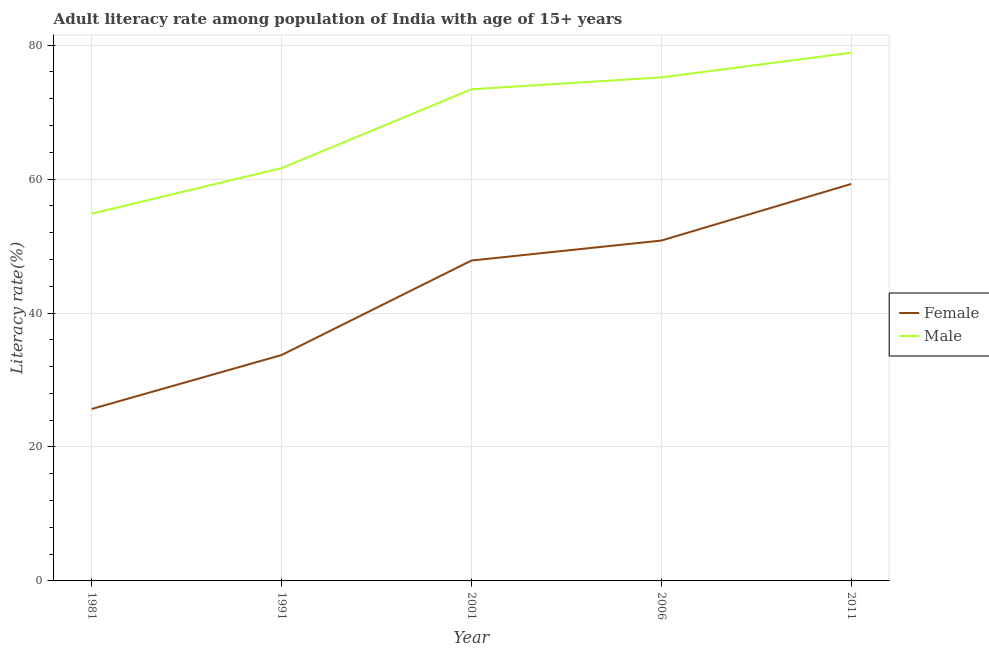How many different coloured lines are there?
Provide a short and direct response. 2. Does the line corresponding to female adult literacy rate intersect with the line corresponding to male adult literacy rate?
Your answer should be compact. No. What is the male adult literacy rate in 2001?
Keep it short and to the point. 73.41. Across all years, what is the maximum female adult literacy rate?
Your answer should be compact. 59.28. Across all years, what is the minimum male adult literacy rate?
Offer a very short reply. 54.84. What is the total male adult literacy rate in the graph?
Your answer should be very brief. 343.96. What is the difference between the female adult literacy rate in 1981 and that in 1991?
Make the answer very short. -8.05. What is the difference between the male adult literacy rate in 1991 and the female adult literacy rate in 2001?
Give a very brief answer. 13.8. What is the average male adult literacy rate per year?
Make the answer very short. 68.79. In the year 1981, what is the difference between the male adult literacy rate and female adult literacy rate?
Give a very brief answer. 29.16. In how many years, is the female adult literacy rate greater than 8 %?
Make the answer very short. 5. What is the ratio of the female adult literacy rate in 2001 to that in 2011?
Provide a short and direct response. 0.81. Is the difference between the female adult literacy rate in 2001 and 2011 greater than the difference between the male adult literacy rate in 2001 and 2011?
Give a very brief answer. No. What is the difference between the highest and the second highest male adult literacy rate?
Offer a terse response. 3.69. What is the difference between the highest and the lowest female adult literacy rate?
Provide a succinct answer. 33.6. Is the sum of the female adult literacy rate in 1991 and 2011 greater than the maximum male adult literacy rate across all years?
Make the answer very short. Yes. Is the female adult literacy rate strictly greater than the male adult literacy rate over the years?
Provide a succinct answer. No. Is the female adult literacy rate strictly less than the male adult literacy rate over the years?
Offer a very short reply. Yes. How many lines are there?
Offer a very short reply. 2. How many years are there in the graph?
Your answer should be compact. 5. What is the difference between two consecutive major ticks on the Y-axis?
Make the answer very short. 20. Are the values on the major ticks of Y-axis written in scientific E-notation?
Keep it short and to the point. No. Does the graph contain any zero values?
Offer a terse response. No. Does the graph contain grids?
Ensure brevity in your answer.  Yes. How are the legend labels stacked?
Your answer should be very brief. Vertical. What is the title of the graph?
Provide a short and direct response. Adult literacy rate among population of India with age of 15+ years. Does "Drinking water services" appear as one of the legend labels in the graph?
Your answer should be compact. No. What is the label or title of the X-axis?
Your response must be concise. Year. What is the label or title of the Y-axis?
Offer a terse response. Literacy rate(%). What is the Literacy rate(%) in Female in 1981?
Your answer should be compact. 25.68. What is the Literacy rate(%) of Male in 1981?
Keep it short and to the point. 54.84. What is the Literacy rate(%) in Female in 1991?
Your answer should be compact. 33.73. What is the Literacy rate(%) in Male in 1991?
Your answer should be very brief. 61.64. What is the Literacy rate(%) of Female in 2001?
Keep it short and to the point. 47.84. What is the Literacy rate(%) of Male in 2001?
Offer a very short reply. 73.41. What is the Literacy rate(%) of Female in 2006?
Give a very brief answer. 50.82. What is the Literacy rate(%) of Male in 2006?
Make the answer very short. 75.19. What is the Literacy rate(%) in Female in 2011?
Give a very brief answer. 59.28. What is the Literacy rate(%) of Male in 2011?
Offer a terse response. 78.88. Across all years, what is the maximum Literacy rate(%) of Female?
Your answer should be very brief. 59.28. Across all years, what is the maximum Literacy rate(%) of Male?
Your answer should be compact. 78.88. Across all years, what is the minimum Literacy rate(%) in Female?
Keep it short and to the point. 25.68. Across all years, what is the minimum Literacy rate(%) of Male?
Give a very brief answer. 54.84. What is the total Literacy rate(%) of Female in the graph?
Make the answer very short. 217.35. What is the total Literacy rate(%) of Male in the graph?
Make the answer very short. 343.96. What is the difference between the Literacy rate(%) in Female in 1981 and that in 1991?
Offer a very short reply. -8.05. What is the difference between the Literacy rate(%) of Male in 1981 and that in 1991?
Offer a terse response. -6.8. What is the difference between the Literacy rate(%) of Female in 1981 and that in 2001?
Provide a short and direct response. -22.17. What is the difference between the Literacy rate(%) of Male in 1981 and that in 2001?
Your answer should be very brief. -18.57. What is the difference between the Literacy rate(%) of Female in 1981 and that in 2006?
Your answer should be compact. -25.15. What is the difference between the Literacy rate(%) of Male in 1981 and that in 2006?
Your answer should be very brief. -20.35. What is the difference between the Literacy rate(%) in Female in 1981 and that in 2011?
Make the answer very short. -33.6. What is the difference between the Literacy rate(%) of Male in 1981 and that in 2011?
Keep it short and to the point. -24.04. What is the difference between the Literacy rate(%) of Female in 1991 and that in 2001?
Give a very brief answer. -14.11. What is the difference between the Literacy rate(%) of Male in 1991 and that in 2001?
Keep it short and to the point. -11.77. What is the difference between the Literacy rate(%) in Female in 1991 and that in 2006?
Your answer should be very brief. -17.09. What is the difference between the Literacy rate(%) in Male in 1991 and that in 2006?
Offer a very short reply. -13.55. What is the difference between the Literacy rate(%) of Female in 1991 and that in 2011?
Give a very brief answer. -25.55. What is the difference between the Literacy rate(%) of Male in 1991 and that in 2011?
Give a very brief answer. -17.24. What is the difference between the Literacy rate(%) of Female in 2001 and that in 2006?
Provide a succinct answer. -2.98. What is the difference between the Literacy rate(%) of Male in 2001 and that in 2006?
Keep it short and to the point. -1.78. What is the difference between the Literacy rate(%) of Female in 2001 and that in 2011?
Make the answer very short. -11.44. What is the difference between the Literacy rate(%) in Male in 2001 and that in 2011?
Provide a short and direct response. -5.47. What is the difference between the Literacy rate(%) in Female in 2006 and that in 2011?
Offer a terse response. -8.45. What is the difference between the Literacy rate(%) of Male in 2006 and that in 2011?
Make the answer very short. -3.69. What is the difference between the Literacy rate(%) in Female in 1981 and the Literacy rate(%) in Male in 1991?
Make the answer very short. -35.97. What is the difference between the Literacy rate(%) in Female in 1981 and the Literacy rate(%) in Male in 2001?
Your answer should be very brief. -47.74. What is the difference between the Literacy rate(%) of Female in 1981 and the Literacy rate(%) of Male in 2006?
Ensure brevity in your answer.  -49.52. What is the difference between the Literacy rate(%) of Female in 1981 and the Literacy rate(%) of Male in 2011?
Your response must be concise. -53.2. What is the difference between the Literacy rate(%) of Female in 1991 and the Literacy rate(%) of Male in 2001?
Your answer should be compact. -39.68. What is the difference between the Literacy rate(%) of Female in 1991 and the Literacy rate(%) of Male in 2006?
Your answer should be very brief. -41.46. What is the difference between the Literacy rate(%) in Female in 1991 and the Literacy rate(%) in Male in 2011?
Ensure brevity in your answer.  -45.15. What is the difference between the Literacy rate(%) in Female in 2001 and the Literacy rate(%) in Male in 2006?
Your response must be concise. -27.35. What is the difference between the Literacy rate(%) in Female in 2001 and the Literacy rate(%) in Male in 2011?
Provide a short and direct response. -31.04. What is the difference between the Literacy rate(%) of Female in 2006 and the Literacy rate(%) of Male in 2011?
Ensure brevity in your answer.  -28.05. What is the average Literacy rate(%) of Female per year?
Give a very brief answer. 43.47. What is the average Literacy rate(%) in Male per year?
Ensure brevity in your answer.  68.79. In the year 1981, what is the difference between the Literacy rate(%) in Female and Literacy rate(%) in Male?
Offer a terse response. -29.16. In the year 1991, what is the difference between the Literacy rate(%) of Female and Literacy rate(%) of Male?
Your answer should be very brief. -27.91. In the year 2001, what is the difference between the Literacy rate(%) in Female and Literacy rate(%) in Male?
Make the answer very short. -25.57. In the year 2006, what is the difference between the Literacy rate(%) in Female and Literacy rate(%) in Male?
Your response must be concise. -24.37. In the year 2011, what is the difference between the Literacy rate(%) in Female and Literacy rate(%) in Male?
Your answer should be very brief. -19.6. What is the ratio of the Literacy rate(%) of Female in 1981 to that in 1991?
Keep it short and to the point. 0.76. What is the ratio of the Literacy rate(%) in Male in 1981 to that in 1991?
Your response must be concise. 0.89. What is the ratio of the Literacy rate(%) of Female in 1981 to that in 2001?
Provide a short and direct response. 0.54. What is the ratio of the Literacy rate(%) of Male in 1981 to that in 2001?
Offer a terse response. 0.75. What is the ratio of the Literacy rate(%) of Female in 1981 to that in 2006?
Offer a terse response. 0.51. What is the ratio of the Literacy rate(%) in Male in 1981 to that in 2006?
Offer a very short reply. 0.73. What is the ratio of the Literacy rate(%) in Female in 1981 to that in 2011?
Offer a very short reply. 0.43. What is the ratio of the Literacy rate(%) of Male in 1981 to that in 2011?
Provide a short and direct response. 0.7. What is the ratio of the Literacy rate(%) of Female in 1991 to that in 2001?
Your response must be concise. 0.7. What is the ratio of the Literacy rate(%) of Male in 1991 to that in 2001?
Provide a short and direct response. 0.84. What is the ratio of the Literacy rate(%) in Female in 1991 to that in 2006?
Your response must be concise. 0.66. What is the ratio of the Literacy rate(%) in Male in 1991 to that in 2006?
Offer a very short reply. 0.82. What is the ratio of the Literacy rate(%) in Female in 1991 to that in 2011?
Provide a short and direct response. 0.57. What is the ratio of the Literacy rate(%) of Male in 1991 to that in 2011?
Your answer should be very brief. 0.78. What is the ratio of the Literacy rate(%) in Female in 2001 to that in 2006?
Make the answer very short. 0.94. What is the ratio of the Literacy rate(%) in Male in 2001 to that in 2006?
Make the answer very short. 0.98. What is the ratio of the Literacy rate(%) of Female in 2001 to that in 2011?
Keep it short and to the point. 0.81. What is the ratio of the Literacy rate(%) of Male in 2001 to that in 2011?
Your answer should be compact. 0.93. What is the ratio of the Literacy rate(%) in Female in 2006 to that in 2011?
Give a very brief answer. 0.86. What is the ratio of the Literacy rate(%) of Male in 2006 to that in 2011?
Give a very brief answer. 0.95. What is the difference between the highest and the second highest Literacy rate(%) in Female?
Your answer should be very brief. 8.45. What is the difference between the highest and the second highest Literacy rate(%) in Male?
Give a very brief answer. 3.69. What is the difference between the highest and the lowest Literacy rate(%) of Female?
Ensure brevity in your answer.  33.6. What is the difference between the highest and the lowest Literacy rate(%) in Male?
Offer a terse response. 24.04. 